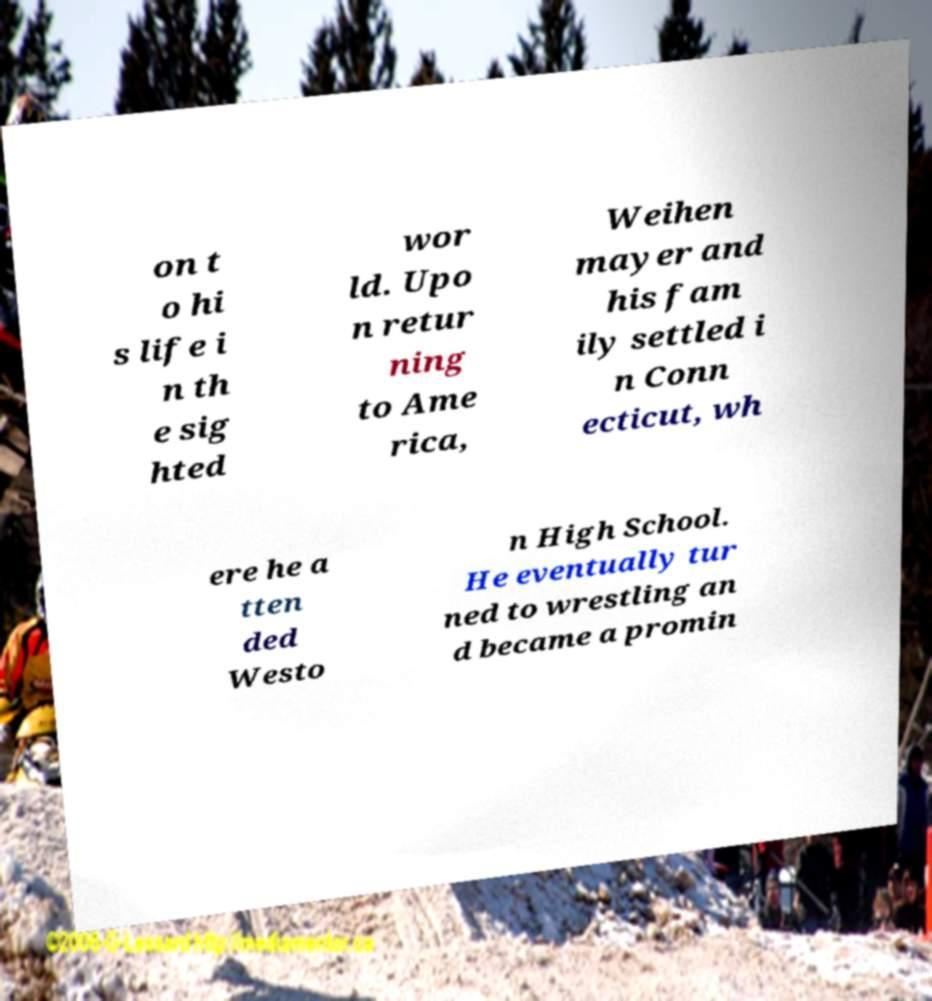Could you extract and type out the text from this image? on t o hi s life i n th e sig hted wor ld. Upo n retur ning to Ame rica, Weihen mayer and his fam ily settled i n Conn ecticut, wh ere he a tten ded Westo n High School. He eventually tur ned to wrestling an d became a promin 